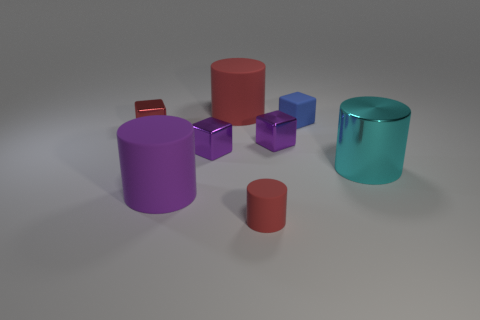Is there a purple thing of the same shape as the cyan shiny object?
Give a very brief answer. Yes. There is a big thing that is behind the large metal cylinder; does it have the same shape as the big object that is in front of the big cyan shiny cylinder?
Your response must be concise. Yes. There is a red thing that is the same size as the shiny cylinder; what material is it?
Your answer should be compact. Rubber. How many other things are there of the same material as the tiny red block?
Offer a terse response. 3. What is the shape of the tiny red object that is on the right side of the red cylinder that is behind the cyan cylinder?
Your answer should be compact. Cylinder. How many things are small purple metallic objects or purple cubes to the right of the tiny rubber cylinder?
Make the answer very short. 2. What number of other things are there of the same color as the tiny rubber cube?
Give a very brief answer. 0. How many blue objects are rubber cubes or cylinders?
Make the answer very short. 1. Are there any small red rubber cylinders on the right side of the big object on the right side of the red rubber object behind the tiny blue rubber object?
Ensure brevity in your answer.  No. Are there any other things that have the same size as the red metal object?
Offer a very short reply. Yes. 